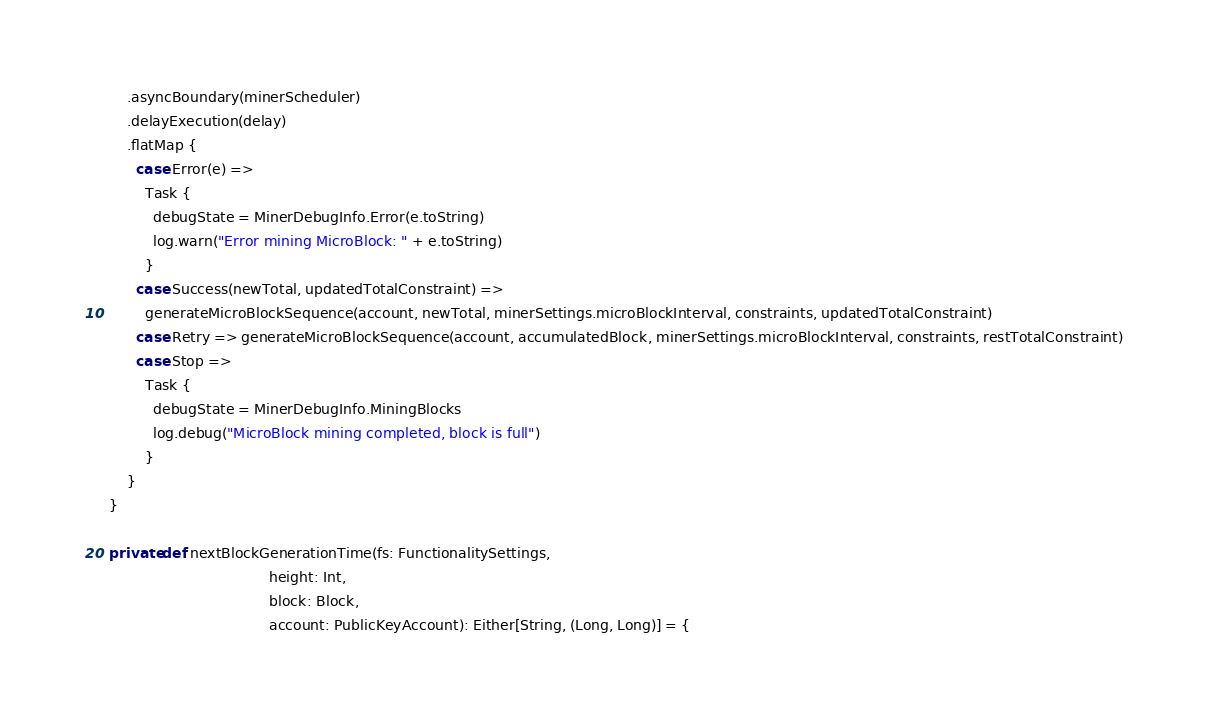<code> <loc_0><loc_0><loc_500><loc_500><_Scala_>      .asyncBoundary(minerScheduler)
      .delayExecution(delay)
      .flatMap {
        case Error(e) =>
          Task {
            debugState = MinerDebugInfo.Error(e.toString)
            log.warn("Error mining MicroBlock: " + e.toString)
          }
        case Success(newTotal, updatedTotalConstraint) =>
          generateMicroBlockSequence(account, newTotal, minerSettings.microBlockInterval, constraints, updatedTotalConstraint)
        case Retry => generateMicroBlockSequence(account, accumulatedBlock, minerSettings.microBlockInterval, constraints, restTotalConstraint)
        case Stop =>
          Task {
            debugState = MinerDebugInfo.MiningBlocks
            log.debug("MicroBlock mining completed, block is full")
          }
      }
  }

  private def nextBlockGenerationTime(fs: FunctionalitySettings,
                                      height: Int,
                                      block: Block,
                                      account: PublicKeyAccount): Either[String, (Long, Long)] = {</code> 